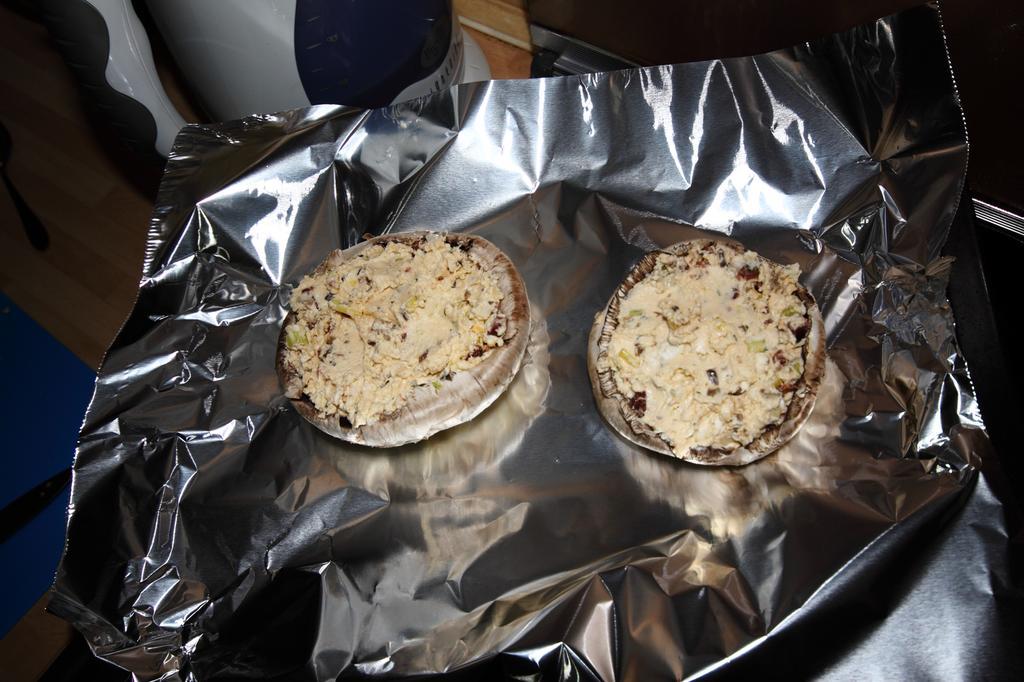Can you describe this image briefly? In this image I can see food item in the aluminium sheet. 